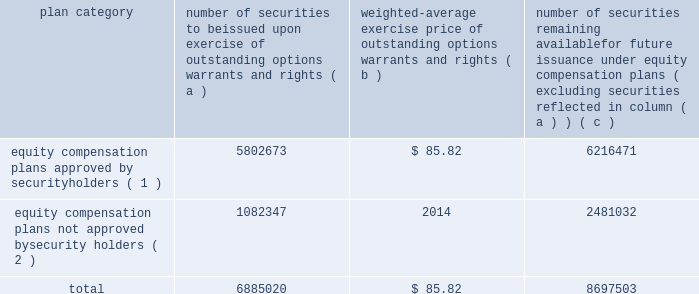Item 12 .
Security ownership of certain beneficial owners and management and related stockholder matters .
The information required by item 12 is included under the heading 201csecurity ownership of management and certain beneficial owners 201d in the 2017 proxy statement , and that information is incorporated by reference in this form 10-k .
Equity compensation plan information the table provides information about our equity compensation plans that authorize the issuance of shares of lockheed martin common stock to employees and directors .
The information is provided as of december 31 , 2016 .
Plan category number of securities to be issued exercise of outstanding options , warrants and rights weighted-average exercise price of outstanding options , warrants and rights number of securities remaining available for future issuance under equity compensation ( excluding securities reflected in column ( a ) ) equity compensation plans approved by security holders ( 1 ) 5802673 $ 85.82 6216471 equity compensation plans not approved by security holders ( 2 ) 1082347 2014 2481032 .
( 1 ) column ( a ) includes , as of december 31 , 2016 : 1747151 shares that have been granted as restricted stock units ( rsus ) , 936308 shares that could be earned pursuant to grants of performance stock units ( psus ) ( assuming the maximum number of psus are earned and payable at the end of the three-year performance period ) and 2967046 shares granted as options under the lockheed martin corporation 2011 incentive performance award plan ( 2011 ipa plan ) or predecessor plans prior to january 1 , 2013 and 23346 shares granted as options and 128822 stock units payable in stock or cash under the lockheed martin corporation 2009 directors equity plan ( directors equity plan ) or predecessor plans for members ( or former members ) of the board of directors .
Column ( c ) includes , as of december 31 , 2016 , 5751655 shares available for future issuance under the 2011 ipa plan as options , stock appreciation rights ( sars ) , restricted stock awards ( rsas ) , rsus or psus and 464816 shares available for future issuance under the directors equity plan as stock options and stock units .
Of the 5751655 shares available for grant under the 2011 ipa plan on december 31 , 2016 , 516653 and 236654 shares are issuable pursuant to grants made on january 26 , 2017 , of rsus and psus ( assuming the maximum number of psus are earned and payable at the end of the three-year performance period ) , respectively .
The weighted average price does not take into account shares issued pursuant to rsus or psus .
( 2 ) the shares represent annual incentive bonuses and long-term incentive performance ( ltip ) payments earned and voluntarily deferred by employees .
The deferred amounts are payable under the deferred management incentive compensation plan ( dmicp ) .
Deferred amounts are credited as phantom stock units at the closing price of our stock on the date the deferral is effective .
Amounts equal to our dividend are credited as stock units at the time we pay a dividend .
Following termination of employment , a number of shares of stock equal to the number of stock units credited to the employee 2019s dmicp account are distributed to the employee .
There is no discount or value transfer on the stock distributed .
Distributions may be made from newly issued shares or shares purchased on the open market .
Historically , all distributions have come from shares held in a separate trust and , therefore , do not further dilute our common shares outstanding .
As a result , these shares also were not considered in calculating the total weighted average exercise price in the table .
Because the dmicp shares are outstanding , they should be included in the denominator ( and not the numerator ) of a dilution calculation .
Item 13 .
Certain relationships and related transactions and director independence .
The information required by this item 13 is included under the captions 201ccorporate governance 2013 related person transaction policy , 201d 201ccorporate governance 2013 certain relationships and related person transactions of directors , executive officers , and 5 percent stockholders , 201d and 201ccorporate governance 2013 director independence 201d in the 2017 proxy statement , and that information is incorporated by reference in this form 10-k .
Item 14 .
Principal accountant fees and services .
The information required by this item 14 is included under the caption 201cproposal 2 2013 ratification of appointment of independent auditors 201d in the 2017 proxy statement , and that information is incorporated by reference in this form 10-k. .
What is the total value of the issued securities approved by security holders , ( in millions ) ? 
Computations: ((5802673 * 85.82) / 1000000)
Answer: 497.9854. 